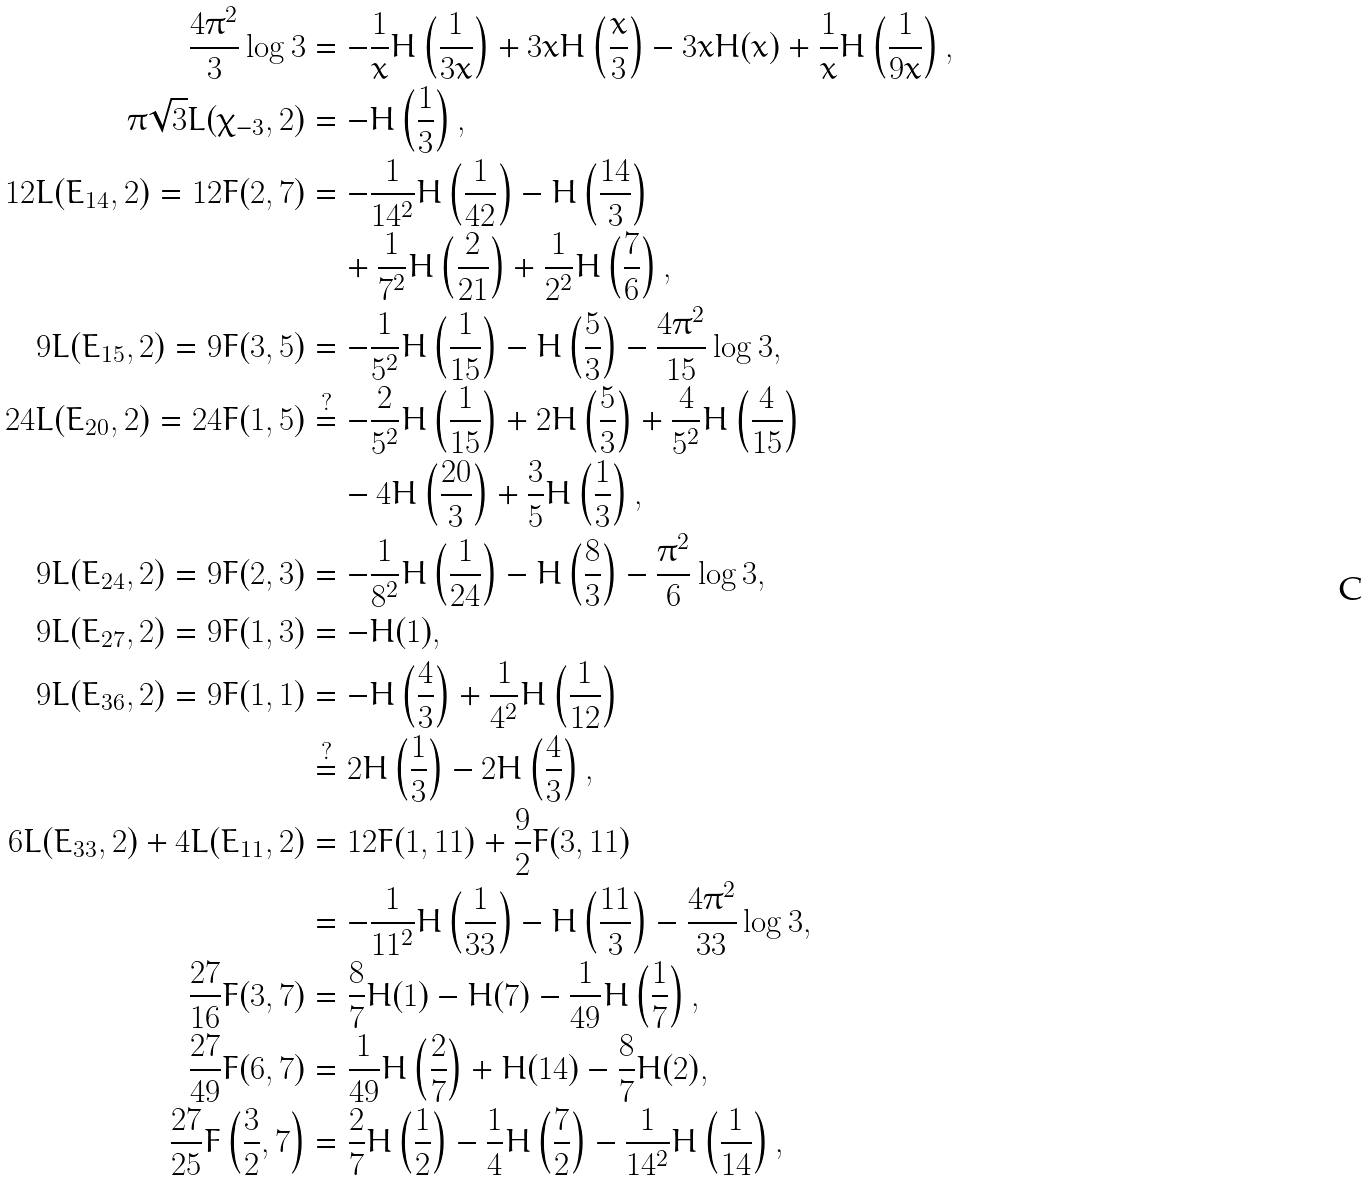Convert formula to latex. <formula><loc_0><loc_0><loc_500><loc_500>\frac { 4 \pi ^ { 2 } } { 3 } \log 3 & = - \frac { 1 } { x } H \left ( \frac { 1 } { 3 x } \right ) + 3 x H \left ( \frac { x } { 3 } \right ) - 3 x H ( x ) + \frac { 1 } { x } H \left ( \frac { 1 } { 9 x } \right ) , \\ \pi \sqrt { 3 } L ( \chi _ { - 3 } , 2 ) & = - H \left ( \frac { 1 } { 3 } \right ) , \\ 1 2 L ( E _ { 1 4 } , 2 ) = 1 2 F ( 2 , 7 ) & = - \frac { 1 } { 1 4 ^ { 2 } } H \left ( \frac { 1 } { 4 2 } \right ) - H \left ( \frac { 1 4 } { 3 } \right ) \\ & \quad + \frac { 1 } { 7 ^ { 2 } } H \left ( \frac { 2 } { 2 1 } \right ) + \frac { 1 } { 2 ^ { 2 } } H \left ( \frac { 7 } { 6 } \right ) , \\ 9 L ( E _ { 1 5 } , 2 ) = 9 F ( 3 , 5 ) & = - \frac { 1 } { 5 ^ { 2 } } H \left ( \frac { 1 } { 1 5 } \right ) - H \left ( \frac { 5 } { 3 } \right ) - \frac { 4 \pi ^ { 2 } } { 1 5 } \log 3 , \\ 2 4 L ( E _ { 2 0 } , 2 ) = 2 4 F ( 1 , 5 ) & \stackrel { ? } { = } - \frac { 2 } { 5 ^ { 2 } } H \left ( \frac { 1 } { 1 5 } \right ) + 2 H \left ( \frac { 5 } { 3 } \right ) + \frac { 4 } { 5 ^ { 2 } } H \left ( \frac { 4 } { 1 5 } \right ) \\ & \quad - 4 H \left ( \frac { 2 0 } { 3 } \right ) + \frac { 3 } { 5 } H \left ( \frac { 1 } { 3 } \right ) , \\ 9 L ( E _ { 2 4 } , 2 ) = 9 F ( 2 , 3 ) & = - \frac { 1 } { 8 ^ { 2 } } H \left ( \frac { 1 } { 2 4 } \right ) - H \left ( \frac { 8 } { 3 } \right ) - \frac { \pi ^ { 2 } } { 6 } \log 3 , \\ 9 L ( E _ { 2 7 } , 2 ) = 9 F ( 1 , 3 ) & = - H ( 1 ) , \\ 9 L ( E _ { 3 6 } , 2 ) = 9 F ( 1 , 1 ) & = - H \left ( \frac { 4 } { 3 } \right ) + \frac { 1 } { 4 ^ { 2 } } H \left ( \frac { 1 } { 1 2 } \right ) \\ & \stackrel { ? } { = } 2 H \left ( \frac { 1 } { 3 } \right ) - 2 H \left ( \frac { 4 } { 3 } \right ) , \\ 6 L ( E _ { 3 3 } , 2 ) + 4 L ( E _ { 1 1 } , 2 ) & = 1 2 F ( 1 , 1 1 ) + \frac { 9 } { 2 } F ( 3 , 1 1 ) \\ & = - \frac { 1 } { 1 1 ^ { 2 } } H \left ( \frac { 1 } { 3 3 } \right ) - H \left ( \frac { 1 1 } { 3 } \right ) - \frac { 4 \pi ^ { 2 } } { 3 3 } \log 3 , \\ \frac { 2 7 } { 1 6 } F ( 3 , 7 ) & = \frac { 8 } { 7 } H ( 1 ) - H ( 7 ) - \frac { 1 } { 4 9 } H \left ( \frac { 1 } { 7 } \right ) , \\ \frac { 2 7 } { 4 9 } F ( 6 , 7 ) & = \frac { 1 } { 4 9 } H \left ( \frac { 2 } { 7 } \right ) + H ( 1 4 ) - \frac { 8 } { 7 } H ( 2 ) , \\ \frac { 2 7 } { 2 5 } F \left ( \frac { 3 } { 2 } , 7 \right ) & = \frac { 2 } { 7 } H \left ( \frac { 1 } { 2 } \right ) - \frac { 1 } { 4 } H \left ( \frac { 7 } { 2 } \right ) - \frac { 1 } { 1 4 ^ { 2 } } H \left ( \frac { 1 } { 1 4 } \right ) ,</formula> 